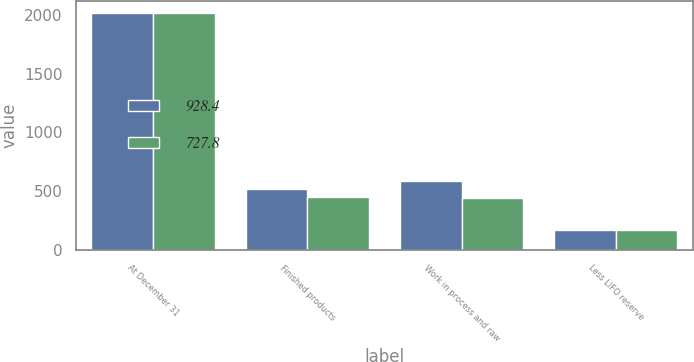<chart> <loc_0><loc_0><loc_500><loc_500><stacked_bar_chart><ecel><fcel>At December 31<fcel>Finished products<fcel>Work in process and raw<fcel>Less LIFO reserve<nl><fcel>928.4<fcel>2017<fcel>515.7<fcel>586.2<fcel>173.5<nl><fcel>727.8<fcel>2016<fcel>452.3<fcel>444.7<fcel>169.2<nl></chart> 